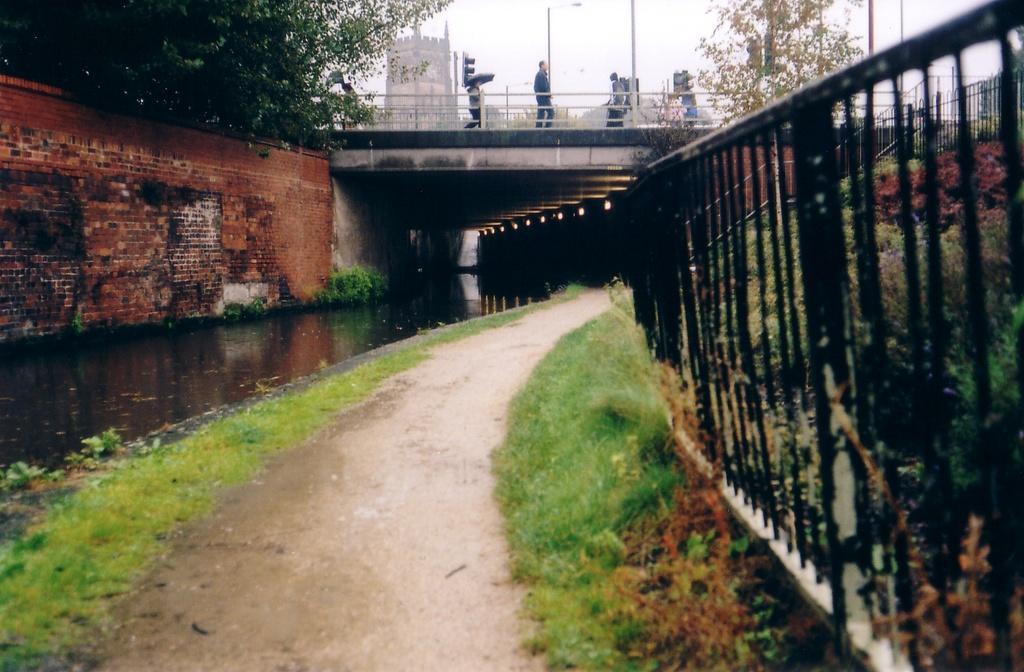Can you describe this image briefly? In the picture we can see a pathway on the either sides of the path we can see grass surface and on the one side, we can see a wall and on the other side, we can see railing and in the background, we can see a bridge and some people are standing on it and we can see some poles and behind it we can see a historical construction, trees and sky. 